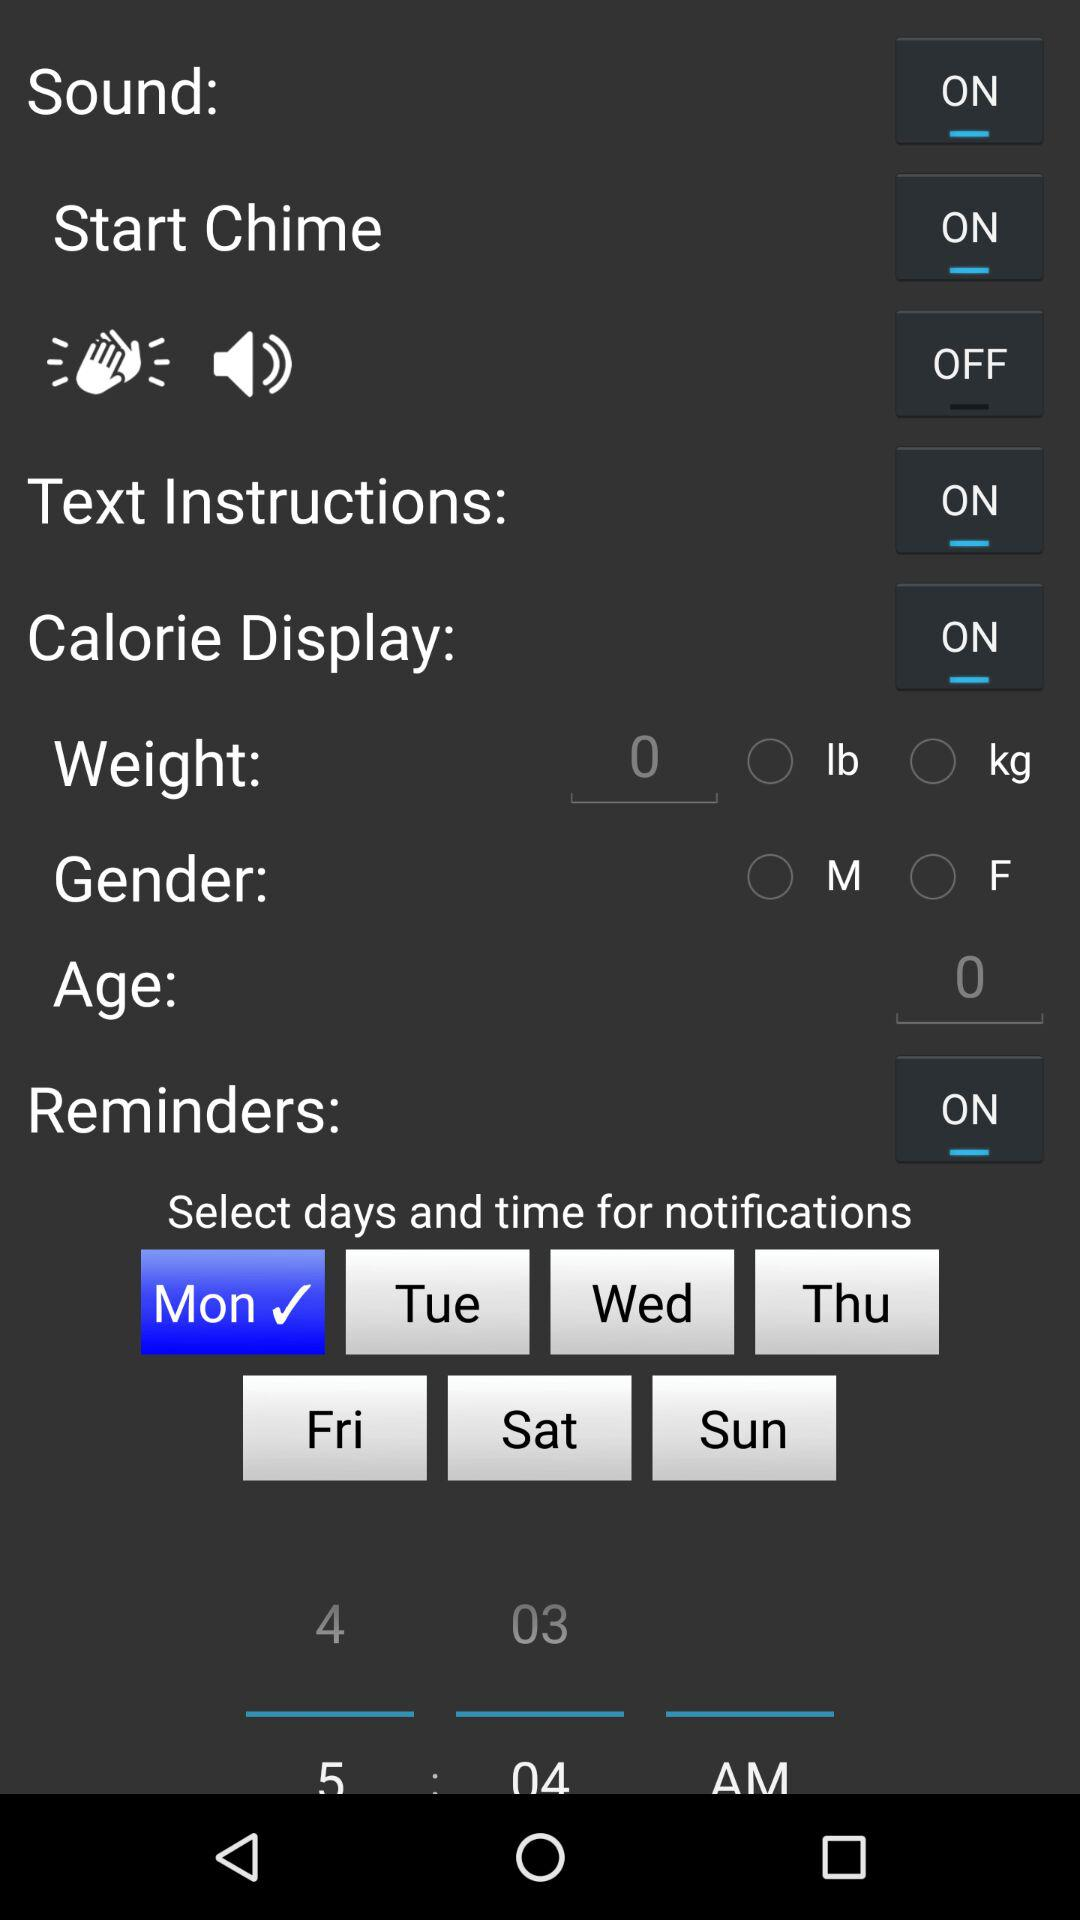What is the status of the "Start Chime"? The status is "on". 